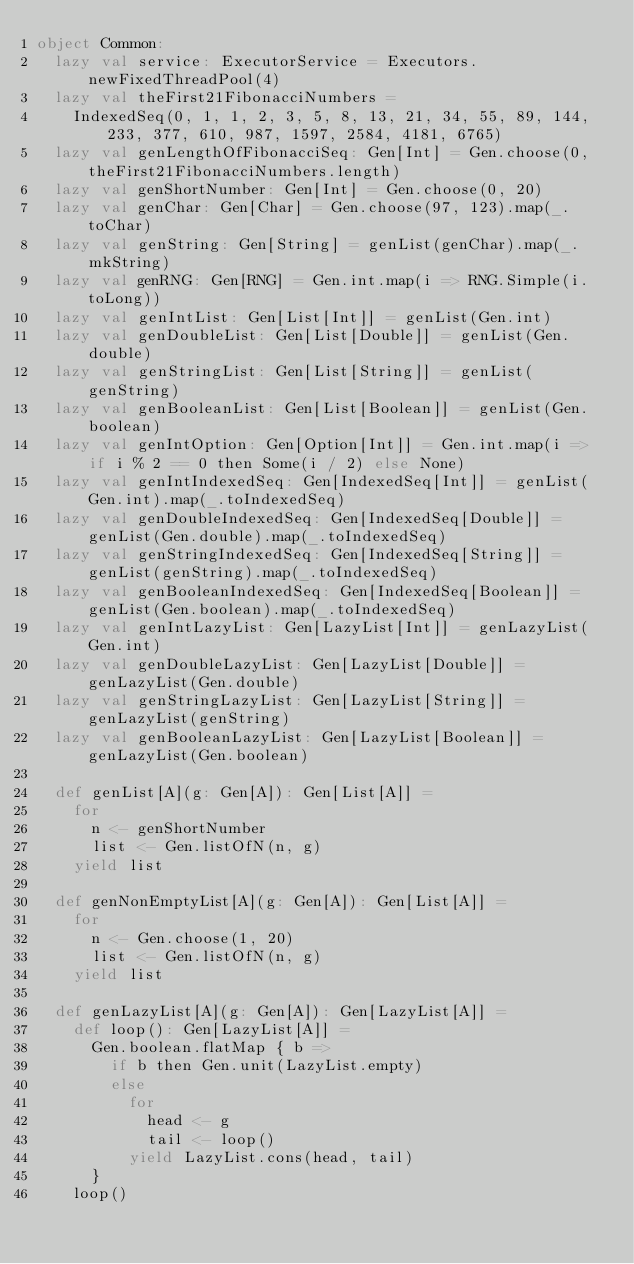<code> <loc_0><loc_0><loc_500><loc_500><_Scala_>object Common:
  lazy val service: ExecutorService = Executors.newFixedThreadPool(4)
  lazy val theFirst21FibonacciNumbers =
    IndexedSeq(0, 1, 1, 2, 3, 5, 8, 13, 21, 34, 55, 89, 144, 233, 377, 610, 987, 1597, 2584, 4181, 6765)
  lazy val genLengthOfFibonacciSeq: Gen[Int] = Gen.choose(0, theFirst21FibonacciNumbers.length)
  lazy val genShortNumber: Gen[Int] = Gen.choose(0, 20)
  lazy val genChar: Gen[Char] = Gen.choose(97, 123).map(_.toChar)
  lazy val genString: Gen[String] = genList(genChar).map(_.mkString)
  lazy val genRNG: Gen[RNG] = Gen.int.map(i => RNG.Simple(i.toLong))
  lazy val genIntList: Gen[List[Int]] = genList(Gen.int)
  lazy val genDoubleList: Gen[List[Double]] = genList(Gen.double)
  lazy val genStringList: Gen[List[String]] = genList(genString)
  lazy val genBooleanList: Gen[List[Boolean]] = genList(Gen.boolean)
  lazy val genIntOption: Gen[Option[Int]] = Gen.int.map(i => if i % 2 == 0 then Some(i / 2) else None)
  lazy val genIntIndexedSeq: Gen[IndexedSeq[Int]] = genList(Gen.int).map(_.toIndexedSeq)
  lazy val genDoubleIndexedSeq: Gen[IndexedSeq[Double]] = genList(Gen.double).map(_.toIndexedSeq)
  lazy val genStringIndexedSeq: Gen[IndexedSeq[String]] = genList(genString).map(_.toIndexedSeq)
  lazy val genBooleanIndexedSeq: Gen[IndexedSeq[Boolean]] = genList(Gen.boolean).map(_.toIndexedSeq)
  lazy val genIntLazyList: Gen[LazyList[Int]] = genLazyList(Gen.int)
  lazy val genDoubleLazyList: Gen[LazyList[Double]] = genLazyList(Gen.double)
  lazy val genStringLazyList: Gen[LazyList[String]] = genLazyList(genString)
  lazy val genBooleanLazyList: Gen[LazyList[Boolean]] = genLazyList(Gen.boolean)

  def genList[A](g: Gen[A]): Gen[List[A]] =
    for
      n <- genShortNumber
      list <- Gen.listOfN(n, g)
    yield list

  def genNonEmptyList[A](g: Gen[A]): Gen[List[A]] =
    for
      n <- Gen.choose(1, 20)
      list <- Gen.listOfN(n, g)
    yield list

  def genLazyList[A](g: Gen[A]): Gen[LazyList[A]] =
    def loop(): Gen[LazyList[A]] =
      Gen.boolean.flatMap { b =>
        if b then Gen.unit(LazyList.empty)
        else
          for
            head <- g
            tail <- loop()
          yield LazyList.cons(head, tail)
      }
    loop()
</code> 